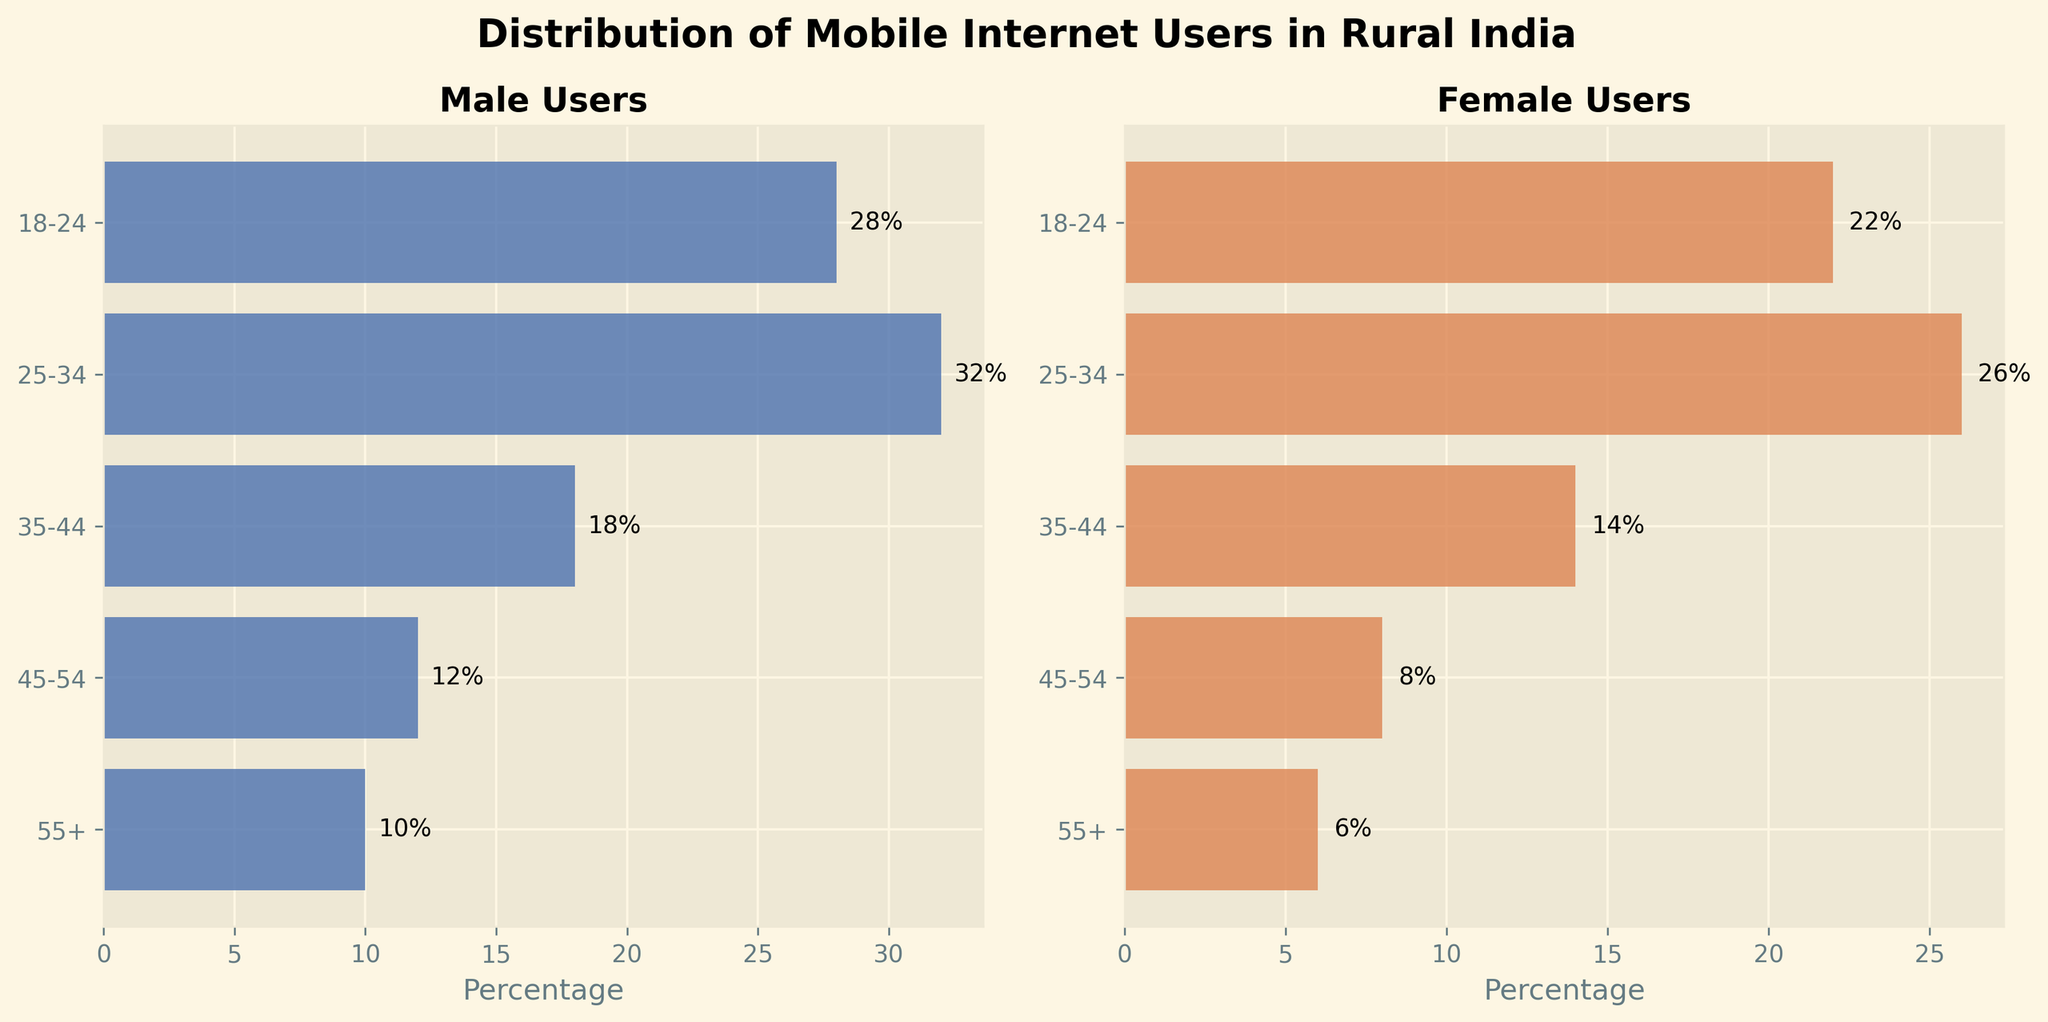What are the titles of the two subplots? The titles of the subplots indicate the categories being displayed. The left subplot is titled "Male Users" and the right subplot is titled "Female Users".
Answer: Male Users and Female Users Which age group has the highest percentage of male mobile internet users? Look for the bar with the highest value in the "Male Users" subplot. The age group with the highest percentage of male users is 25-34 with 32%.
Answer: 25-34 How many age groups are represented in each subplot? Count the number of bars in either subplot. Both subplots have the same age groups: 18-24, 25-34, 35-44, 45-54, and 55+.
Answer: 5 What is the percentage difference in mobile internet usage between males and females in the 18-24 age group? Subtract the percentage of female users (22%) from the percentage of male users (28%) for the 18-24 age group. The difference is 28% - 22% = 6%.
Answer: 6% Which age group has the smallest percentage of female mobile internet users? Look for the shortest bar in the "Female Users" subplot. The age group with the smallest percentage of female users is 55+ with 6%.
Answer: 55+ Compare the percentage of mobile internet users in the 25-34 and 35-44 age groups for both males and females. In the "Male Users" subplot, 25-34 has 32% and 35-44 has 18%, the difference is 32%-18%=14%. In the "Female Users" subplot, 25-34 has 26% and 35-44 has 14%, the difference is 26%-14%=12%. Both subplots show a higher percentage in the 25-34 age group compared to the 35-44 age group.
Answer: 25-34 has higher percentages with 14% more males and 12% more females What is the total percentage of mobile internet users (both genders) in the 45-54 age group? Add the percentages of male (12%) and female (8%) users in the 45-54 age group. The total is 12% + 8% = 20%.
Answer: 20% What percentage of mobile internet users are female in the 18-24 and 35-44 age groups combined? Add the percentages for female users in both age groups: 22% (18-24) and 14% (35-44). The combined percentage is 22% + 14% = 36%.
Answer: 36% In which age group is the gap between male and female mobile internet users the largest? Calculate the differences for each age group: 
- 18-24 (28%-22%=6%)
- 25-34 (32%-26%=6%)
- 35-44 (18%-14%=4%)
- 45-54 (12%-8%=4%)
- 55+ (10%-6%=4%)
The largest gap is found in the 18-24 and 25-34 age groups with a difference of 6%.
Answer: 18-24 and 25-34 